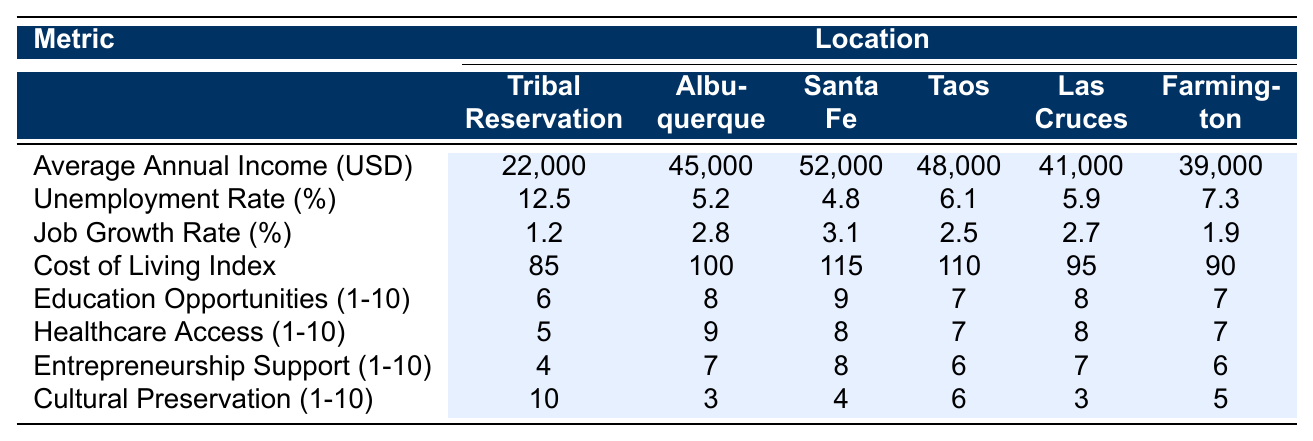What is the average annual income in the Tribal Reservation? The table shows the average annual income for the Tribal Reservation is 22,000 USD, listed under the "Average Annual Income (USD)" metric.
Answer: 22,000 USD Which location has the lowest unemployment rate? Looking at the "Unemployment Rate (%)" row, Albuquerque has the lowest unemployment rate at 5.2%.
Answer: Albuquerque What is the job growth rate in Las Cruces? According to the "Job Growth Rate (%)" metric in the table, Las Cruces has a job growth rate of 2.7%.
Answer: 2.7% What is the average cost of living index across all the locations? To find the average, sum all the cost of living indices: (85 + 100 + 115 + 110 + 95 + 90) = 595. There are 6 locations, so the average is 595/6 = 99.17, rounded to 99.
Answer: 99 Is the education opportunity score in the Tribal Reservation higher than that in Santa Fe? The education opportunity score for the Tribal Reservation is 6 while Santa Fe's score is 9. Since 6 is not greater than 9, the answer is no.
Answer: No What is the difference in cultural preservation scores between the Tribal Reservation and Albuquerque? The score for cultural preservation in the Tribal Reservation is 10, and in Albuquerque, it is 3. The difference is 10 - 3 = 7.
Answer: 7 How does the average annual income in the Tribal Reservation compare to that of Albuquerque? The average annual income in the Tribal Reservation is 22,000 USD and in Albuquerque, it is 45,000 USD. Therefore, Albuquerque's income is higher by 45,000 - 22,000 = 23,000 USD.
Answer: 23,000 USD Which location offers the highest healthcare access score? Reviewing the "Healthcare Access (1-10 scale)" row, Albuquerque scores 9, which is the highest amongst the locations.
Answer: Albuquerque Is the cost of living index for the Tribal Reservation lower than the average across all locations? The cost of living index for the Tribal Reservation is 85. The average cost of living index is 99.17, showing that 85 is indeed lower.
Answer: Yes What is the average entrepreneurship support score across all locations? To find the average, sum the entrepreneurship support scores: (4 + 7 + 8 + 6 + 7 + 6) = 38. Dividing by 6 (the number of locations), the average is 38/6 = 6.33, rounded to 6.
Answer: 6 